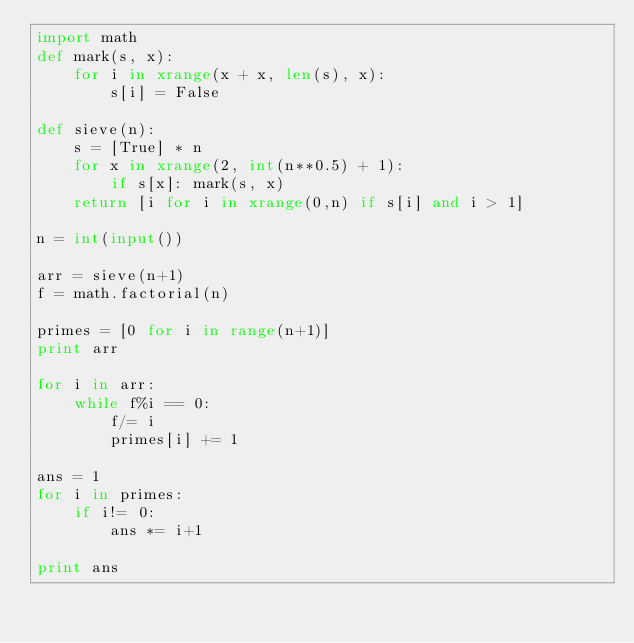<code> <loc_0><loc_0><loc_500><loc_500><_Python_>import math
def mark(s, x):
    for i in xrange(x + x, len(s), x):
        s[i] = False

def sieve(n):
    s = [True] * n
    for x in xrange(2, int(n**0.5) + 1):
        if s[x]: mark(s, x)
    return [i for i in xrange(0,n) if s[i] and i > 1]

n = int(input())

arr = sieve(n+1)
f = math.factorial(n)

primes = [0 for i in range(n+1)]
print arr

for i in arr:
	while f%i == 0:
		f/= i
		primes[i] += 1

ans = 1
for i in primes:
	if i!= 0:
		ans *= i+1

print ans</code> 